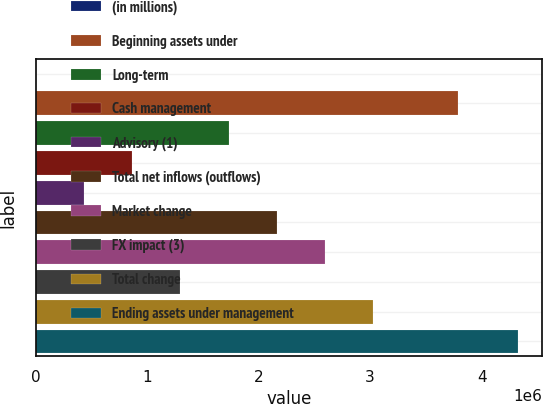Convert chart to OTSL. <chart><loc_0><loc_0><loc_500><loc_500><bar_chart><fcel>(in millions)<fcel>Beginning assets under<fcel>Long-term<fcel>Cash management<fcel>Advisory (1)<fcel>Total net inflows (outflows)<fcel>Market change<fcel>FX impact (3)<fcel>Total change<fcel>Ending assets under management<nl><fcel>2013<fcel>3.79159e+06<fcel>1.73084e+06<fcel>866428<fcel>434220<fcel>2.16305e+06<fcel>2.59526e+06<fcel>1.29864e+06<fcel>3.02747e+06<fcel>4.32409e+06<nl></chart> 